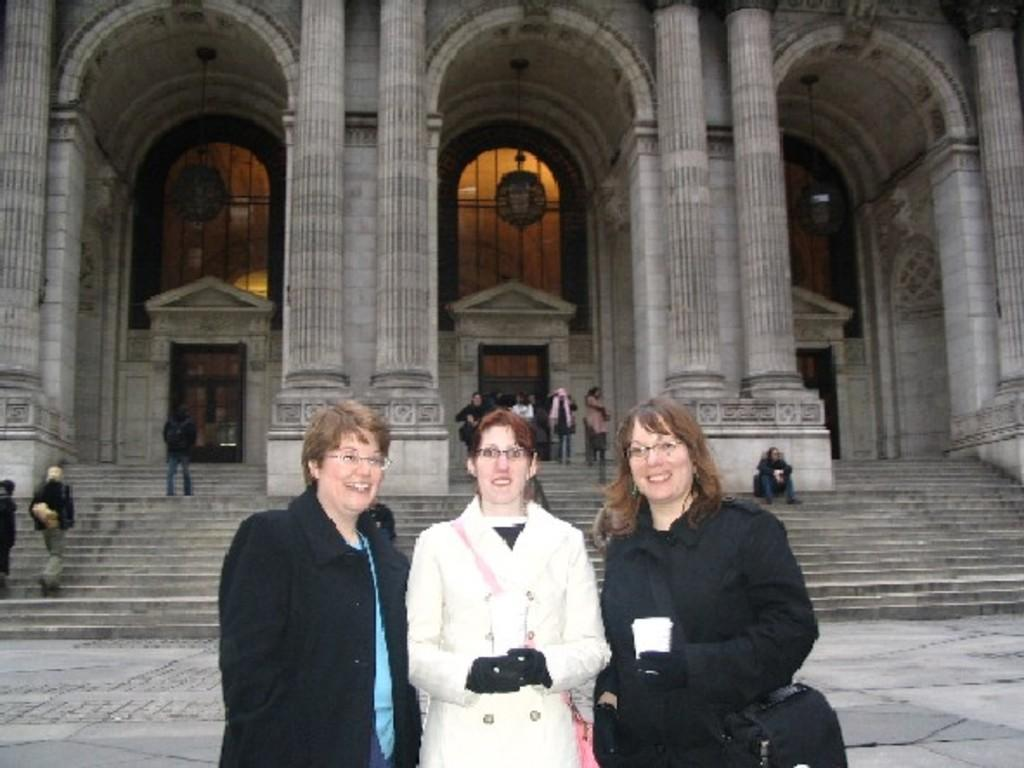Who or what is present in the image? There are people in the image. What architectural feature can be seen in the image? There are stairs in the image. What can be seen in the background of the image? There is a building in the background of the image. What type of advertisement can be seen on the fork in the image? There is no fork present in the image, so it is not possible to determine if there is an advertisement on it. 